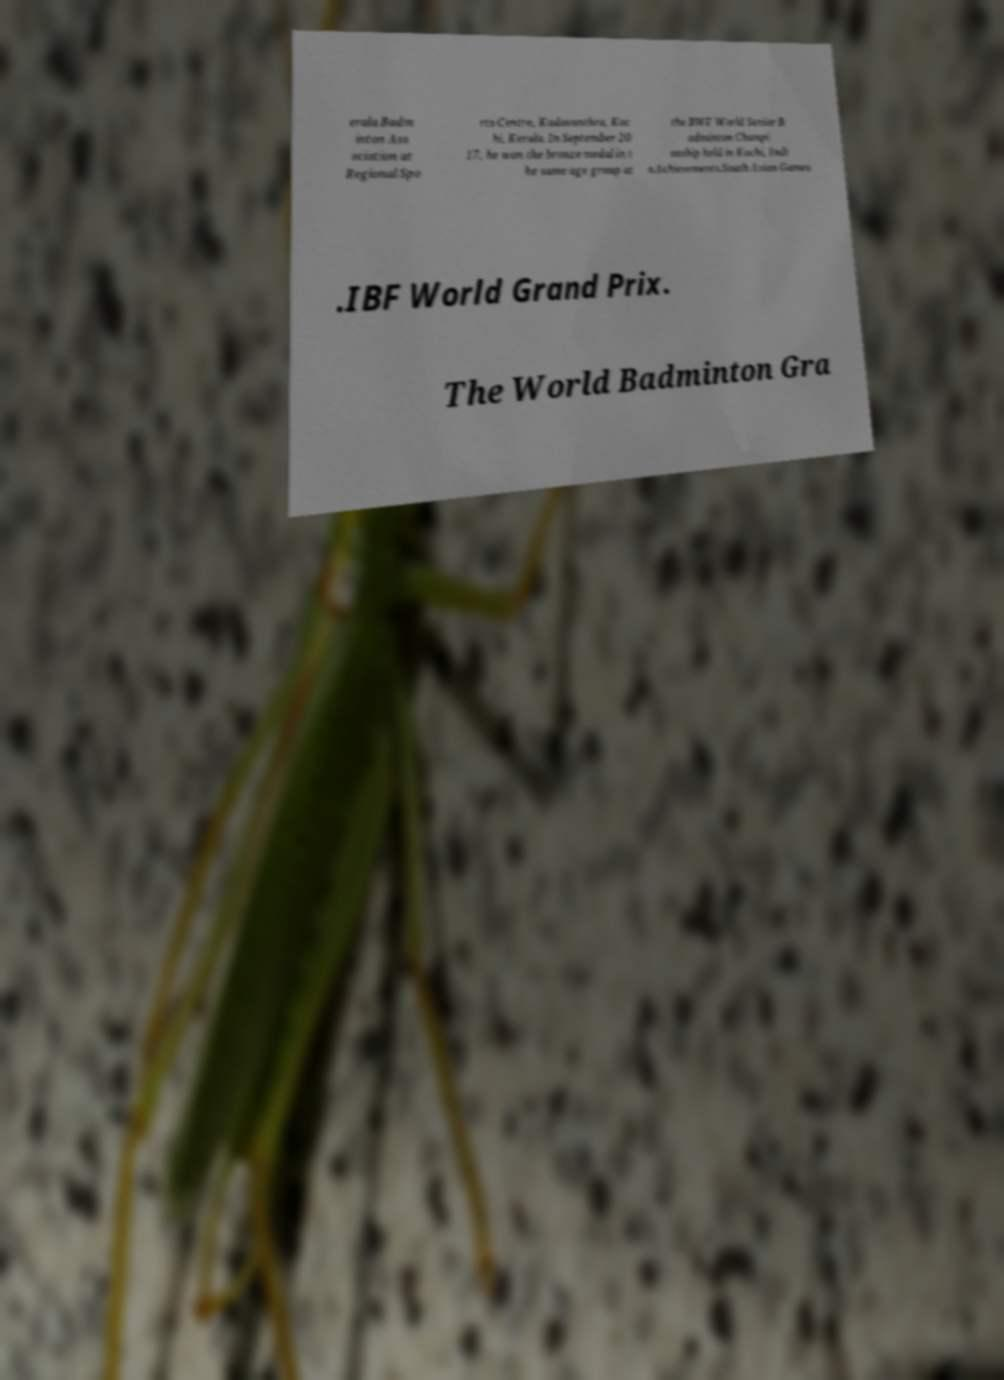Could you extract and type out the text from this image? erala Badm inton Ass ociation at Regional Spo rts Centre, Kadavanthra, Koc hi, Kerala. In September 20 17, he won the bronze medal in t he same age group at the BWF World Senior B adminton Champi onship held in Kochi, Indi a.Achievements.South Asian Games .IBF World Grand Prix. The World Badminton Gra 